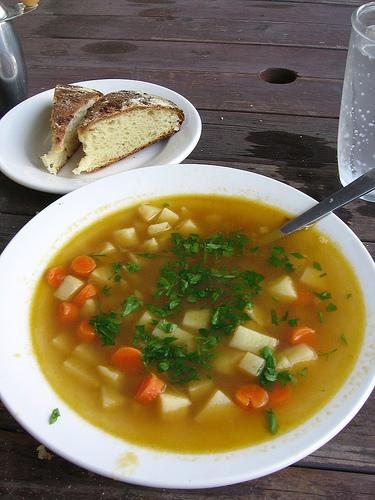What are the contents of the white bowl on the table? The white bowl contains vegetable soup with carrots, potatoes, parsley, and green flakes. Analyze the object interaction in the image, particularly among food items. The silver spoon is placed in the bowl of soup, immersed in the vegetables, while pieces of bread are arranged on a white plate near the bowl. What type of room setting do you think this image is portraying? The image portrays an informal dining setting, possibly an outdoor picnic table. Explain the scenario in the simplest way without using numbers or specific objects. A table is set with various dishes and a drink, with food spread across the surface. Describe any peculiar characteristics of the table in the image. The table has a hole cut into it and displays wet spots on its wooden surface. Mention the drink beside the bowl of soup and its location. A clear glass of water is located to the right of the bowl of soup. Create a brief summary of the entire scene in the image. A wooden table set with a bowl of vegetable soup, sliced carrots, a white plate containing two pieces of bread, a silver spoon, a clear glass of water, and a silver metal container. Count the total number of carrot pieces visible in the image. There are seven visible carrot pieces in the image. What is the overall sentiment or atmosphere portrayed in the image? The image conveys a cozy and casual dining experience, likely enjoyed among friends or family. Identify any holes or openings that are visible in the image. There is a hole in the wooden table and an opening in the silverware handle stuck in the soup. Take a close look at the purple flower vase sitting on the wooden table. It really adds a touch of elegance to the scene. There is no flower vase mentioned in the object list, let alone a purple one. This instruction is misleading as it introduces a completely new object that doesn't exist in the image. Notice the steam coming from the hot soup in the white bowl. It must be fresh and delicious. No, it's not mentioned in the image. Can you spot the banana on the table? There's a yellow banana lying next to the bowl of soup.  There's no mention of a banana anywhere in the image's object list, so it's a misleading statement to include an object that isn't there. Are the chocolate chip cookies on the white side plate? The dessert looks tempting beside the slices of bread. No chocolate chip cookies or dessert items are mentioned in the object list of the image. This instruction is misleading as it introduces an unrelated, non-existent item. Did you notice the little red toy car parked near the legs of the table? It seems someone left it there during a picnic. There is no mention of a toy car or any similar object in the image's object list. This instruction is misleading as it suggests an object that is not present in the scene. Is the blue napkin folded neatly on the table? The table setting appears to be very organized. There is no mention of a blue napkin or any napkin for that matter in the image's object list. This instruction misleads the viewer by directing their attention towards something non-existent. 